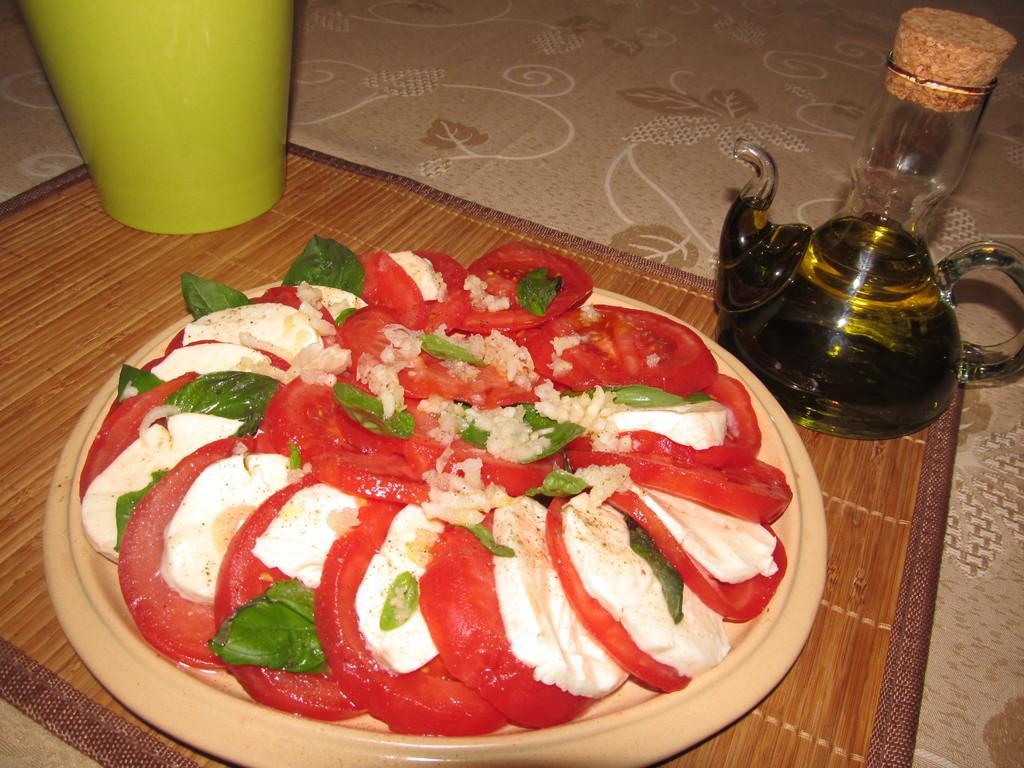In one or two sentences, can you explain what this image depicts? In this image I can see the cream and brown colored surface and on it I can see a wooden sheet. On the sheet I can see a teapot, a cream colored plate with food item on it which is red, white and green in color and a green colored glass. I can see a glass with brown colored object on it. 